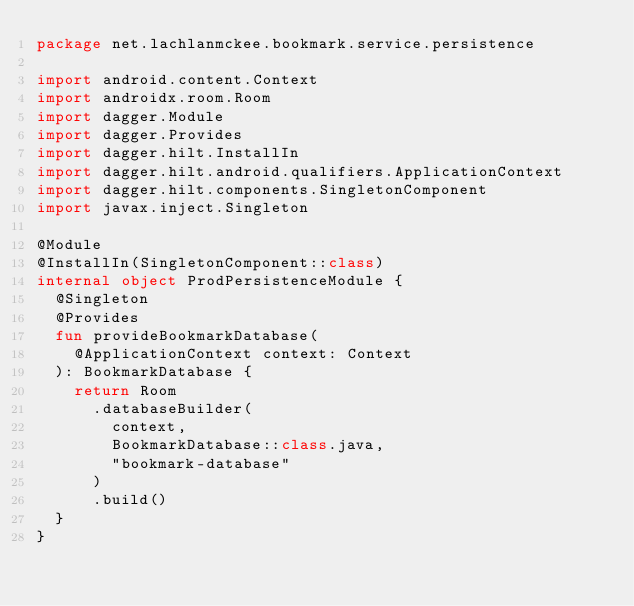Convert code to text. <code><loc_0><loc_0><loc_500><loc_500><_Kotlin_>package net.lachlanmckee.bookmark.service.persistence

import android.content.Context
import androidx.room.Room
import dagger.Module
import dagger.Provides
import dagger.hilt.InstallIn
import dagger.hilt.android.qualifiers.ApplicationContext
import dagger.hilt.components.SingletonComponent
import javax.inject.Singleton

@Module
@InstallIn(SingletonComponent::class)
internal object ProdPersistenceModule {
  @Singleton
  @Provides
  fun provideBookmarkDatabase(
    @ApplicationContext context: Context
  ): BookmarkDatabase {
    return Room
      .databaseBuilder(
        context,
        BookmarkDatabase::class.java,
        "bookmark-database"
      )
      .build()
  }
}
</code> 